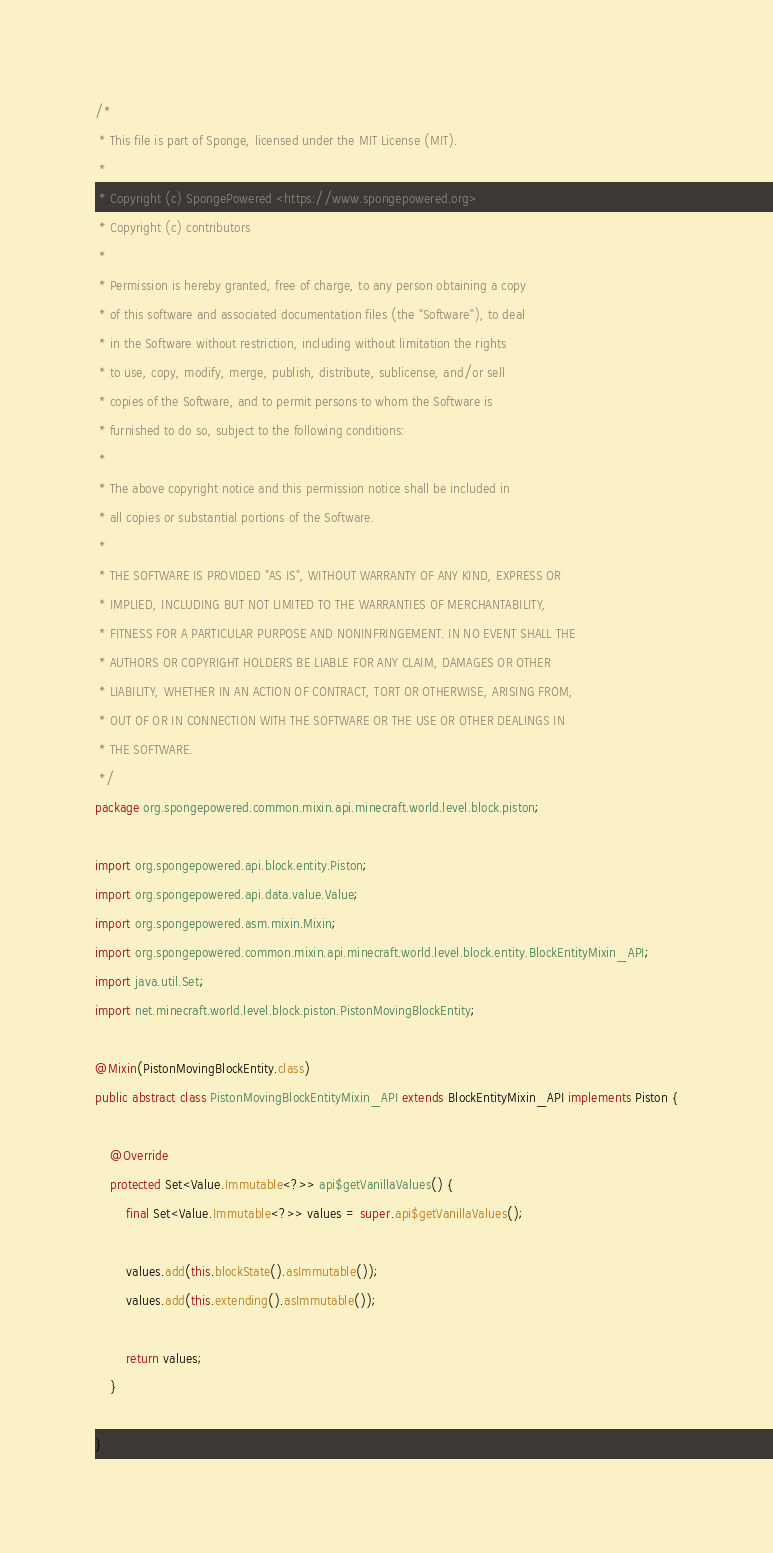Convert code to text. <code><loc_0><loc_0><loc_500><loc_500><_Java_>/*
 * This file is part of Sponge, licensed under the MIT License (MIT).
 *
 * Copyright (c) SpongePowered <https://www.spongepowered.org>
 * Copyright (c) contributors
 *
 * Permission is hereby granted, free of charge, to any person obtaining a copy
 * of this software and associated documentation files (the "Software"), to deal
 * in the Software without restriction, including without limitation the rights
 * to use, copy, modify, merge, publish, distribute, sublicense, and/or sell
 * copies of the Software, and to permit persons to whom the Software is
 * furnished to do so, subject to the following conditions:
 *
 * The above copyright notice and this permission notice shall be included in
 * all copies or substantial portions of the Software.
 *
 * THE SOFTWARE IS PROVIDED "AS IS", WITHOUT WARRANTY OF ANY KIND, EXPRESS OR
 * IMPLIED, INCLUDING BUT NOT LIMITED TO THE WARRANTIES OF MERCHANTABILITY,
 * FITNESS FOR A PARTICULAR PURPOSE AND NONINFRINGEMENT. IN NO EVENT SHALL THE
 * AUTHORS OR COPYRIGHT HOLDERS BE LIABLE FOR ANY CLAIM, DAMAGES OR OTHER
 * LIABILITY, WHETHER IN AN ACTION OF CONTRACT, TORT OR OTHERWISE, ARISING FROM,
 * OUT OF OR IN CONNECTION WITH THE SOFTWARE OR THE USE OR OTHER DEALINGS IN
 * THE SOFTWARE.
 */
package org.spongepowered.common.mixin.api.minecraft.world.level.block.piston;

import org.spongepowered.api.block.entity.Piston;
import org.spongepowered.api.data.value.Value;
import org.spongepowered.asm.mixin.Mixin;
import org.spongepowered.common.mixin.api.minecraft.world.level.block.entity.BlockEntityMixin_API;
import java.util.Set;
import net.minecraft.world.level.block.piston.PistonMovingBlockEntity;

@Mixin(PistonMovingBlockEntity.class)
public abstract class PistonMovingBlockEntityMixin_API extends BlockEntityMixin_API implements Piston {

    @Override
    protected Set<Value.Immutable<?>> api$getVanillaValues() {
        final Set<Value.Immutable<?>> values = super.api$getVanillaValues();

        values.add(this.blockState().asImmutable());
        values.add(this.extending().asImmutable());

        return values;
    }

}
</code> 